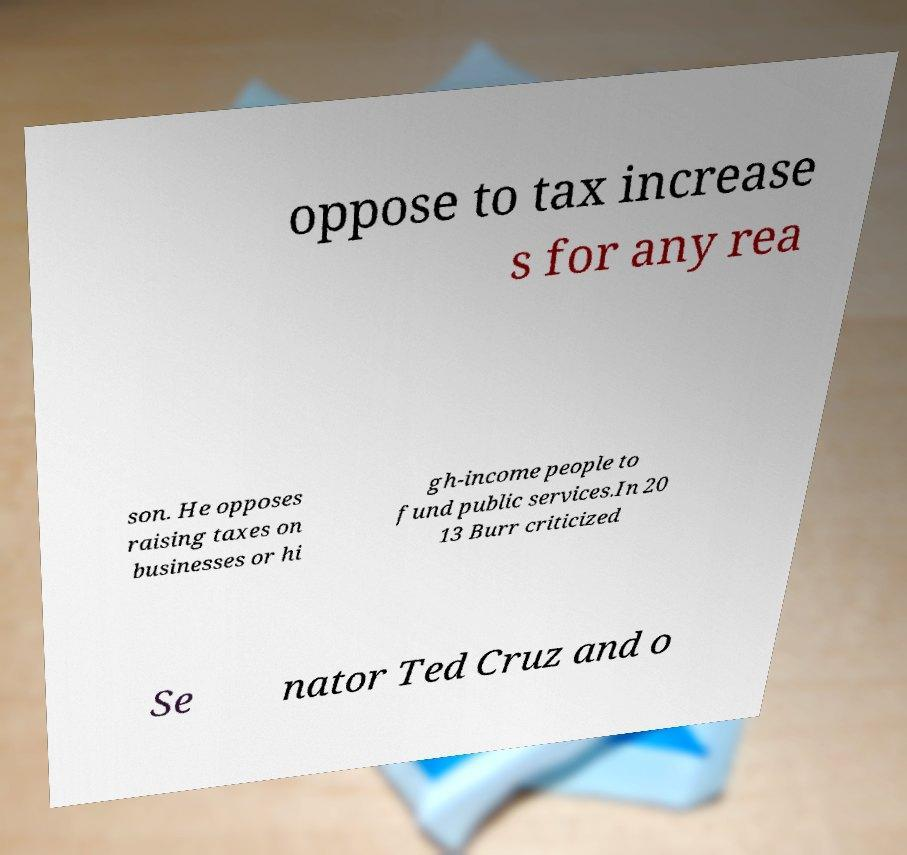Can you read and provide the text displayed in the image?This photo seems to have some interesting text. Can you extract and type it out for me? oppose to tax increase s for any rea son. He opposes raising taxes on businesses or hi gh-income people to fund public services.In 20 13 Burr criticized Se nator Ted Cruz and o 